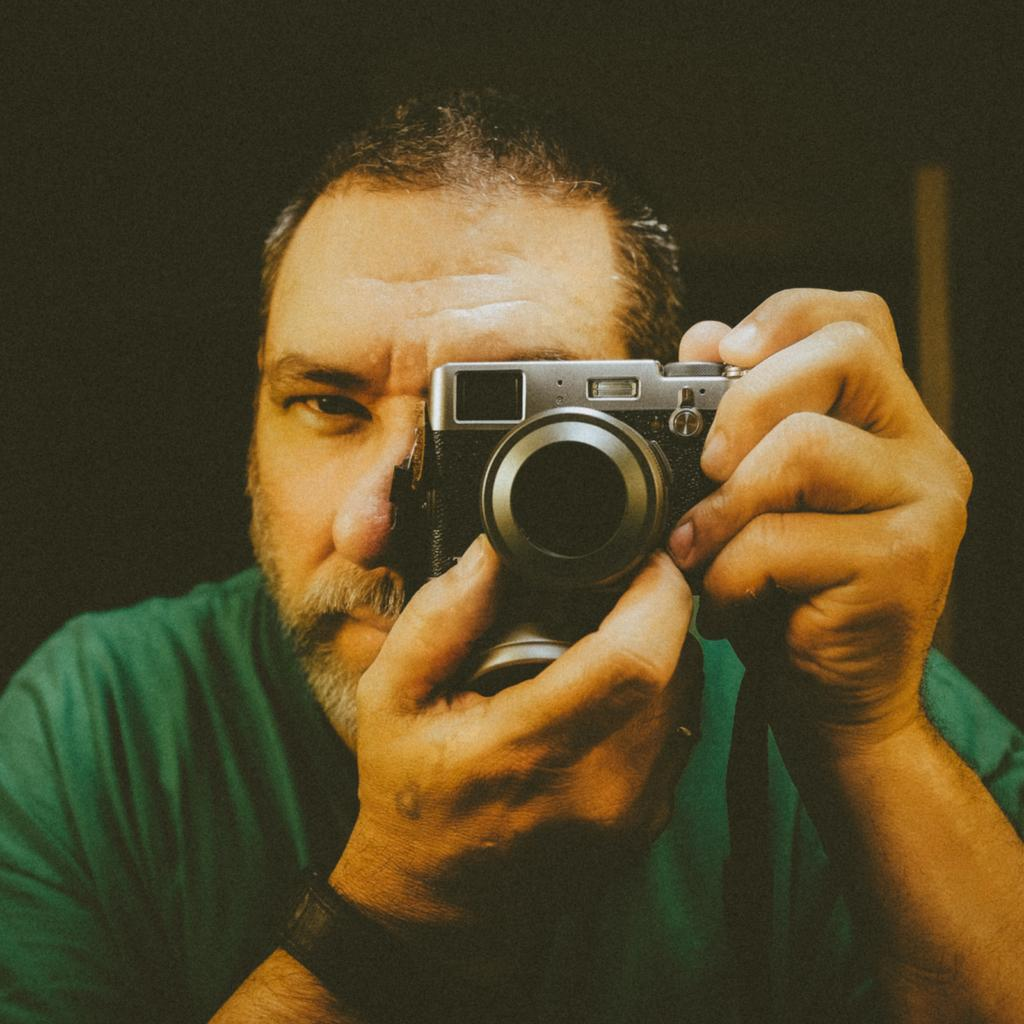What is the main subject of the image? There is a person in the image. What is the person holding in the image? The person is holding a camera. What type of balls can be seen in the image? There are no balls present in the image; it features a person holding a camera. What type of paint is being used by the person in the image? There is no paint or painting activity depicted in the image; the person is holding a camera. 